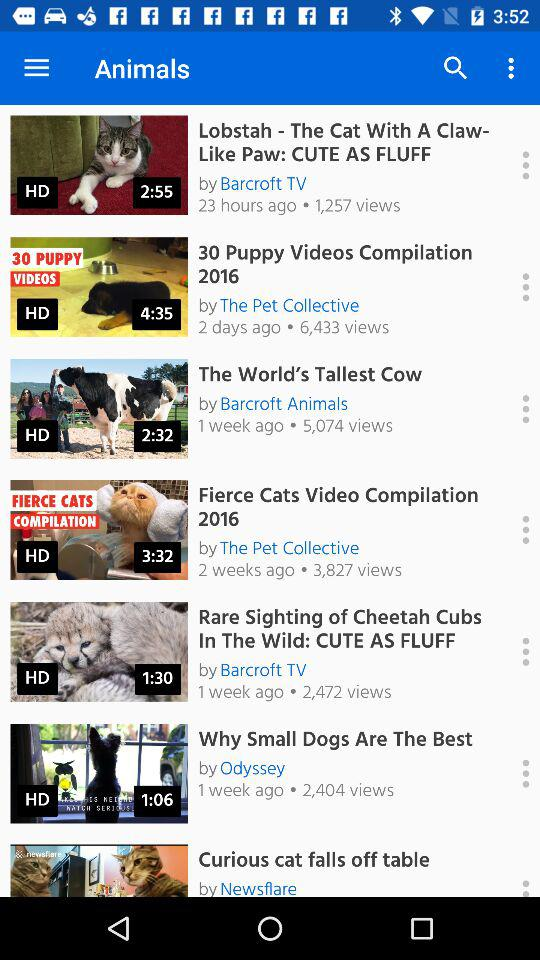How many views does the video "Lobstah" have? The video has 1,257 views. 